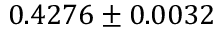<formula> <loc_0><loc_0><loc_500><loc_500>0 . 4 2 7 6 \pm 0 . 0 0 3 2</formula> 